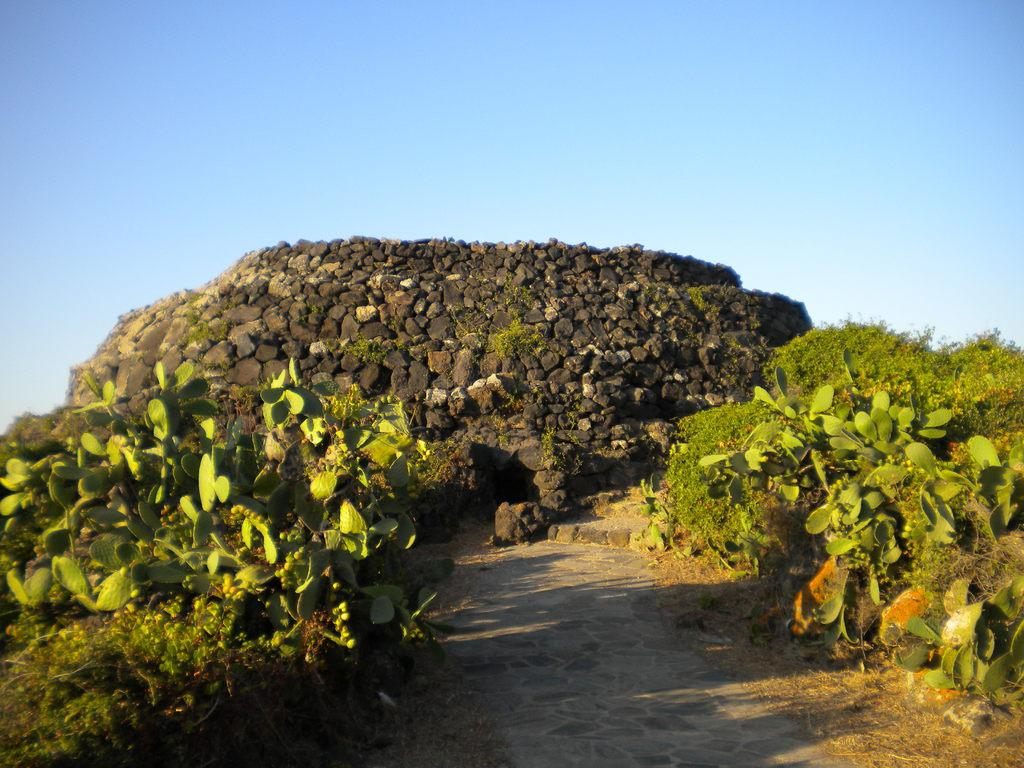What can be seen on both sides of the path in the image? There are trees on either side of the path in the image. What type of structure is visible in the image? There is a cave made with stones in the image. What color is the sky in the image? The sky is blue in the image. Where is the sheep in the image? There is no sheep present in the image. What does the dad say in the image? There is no dad or dialogue present in the image. 